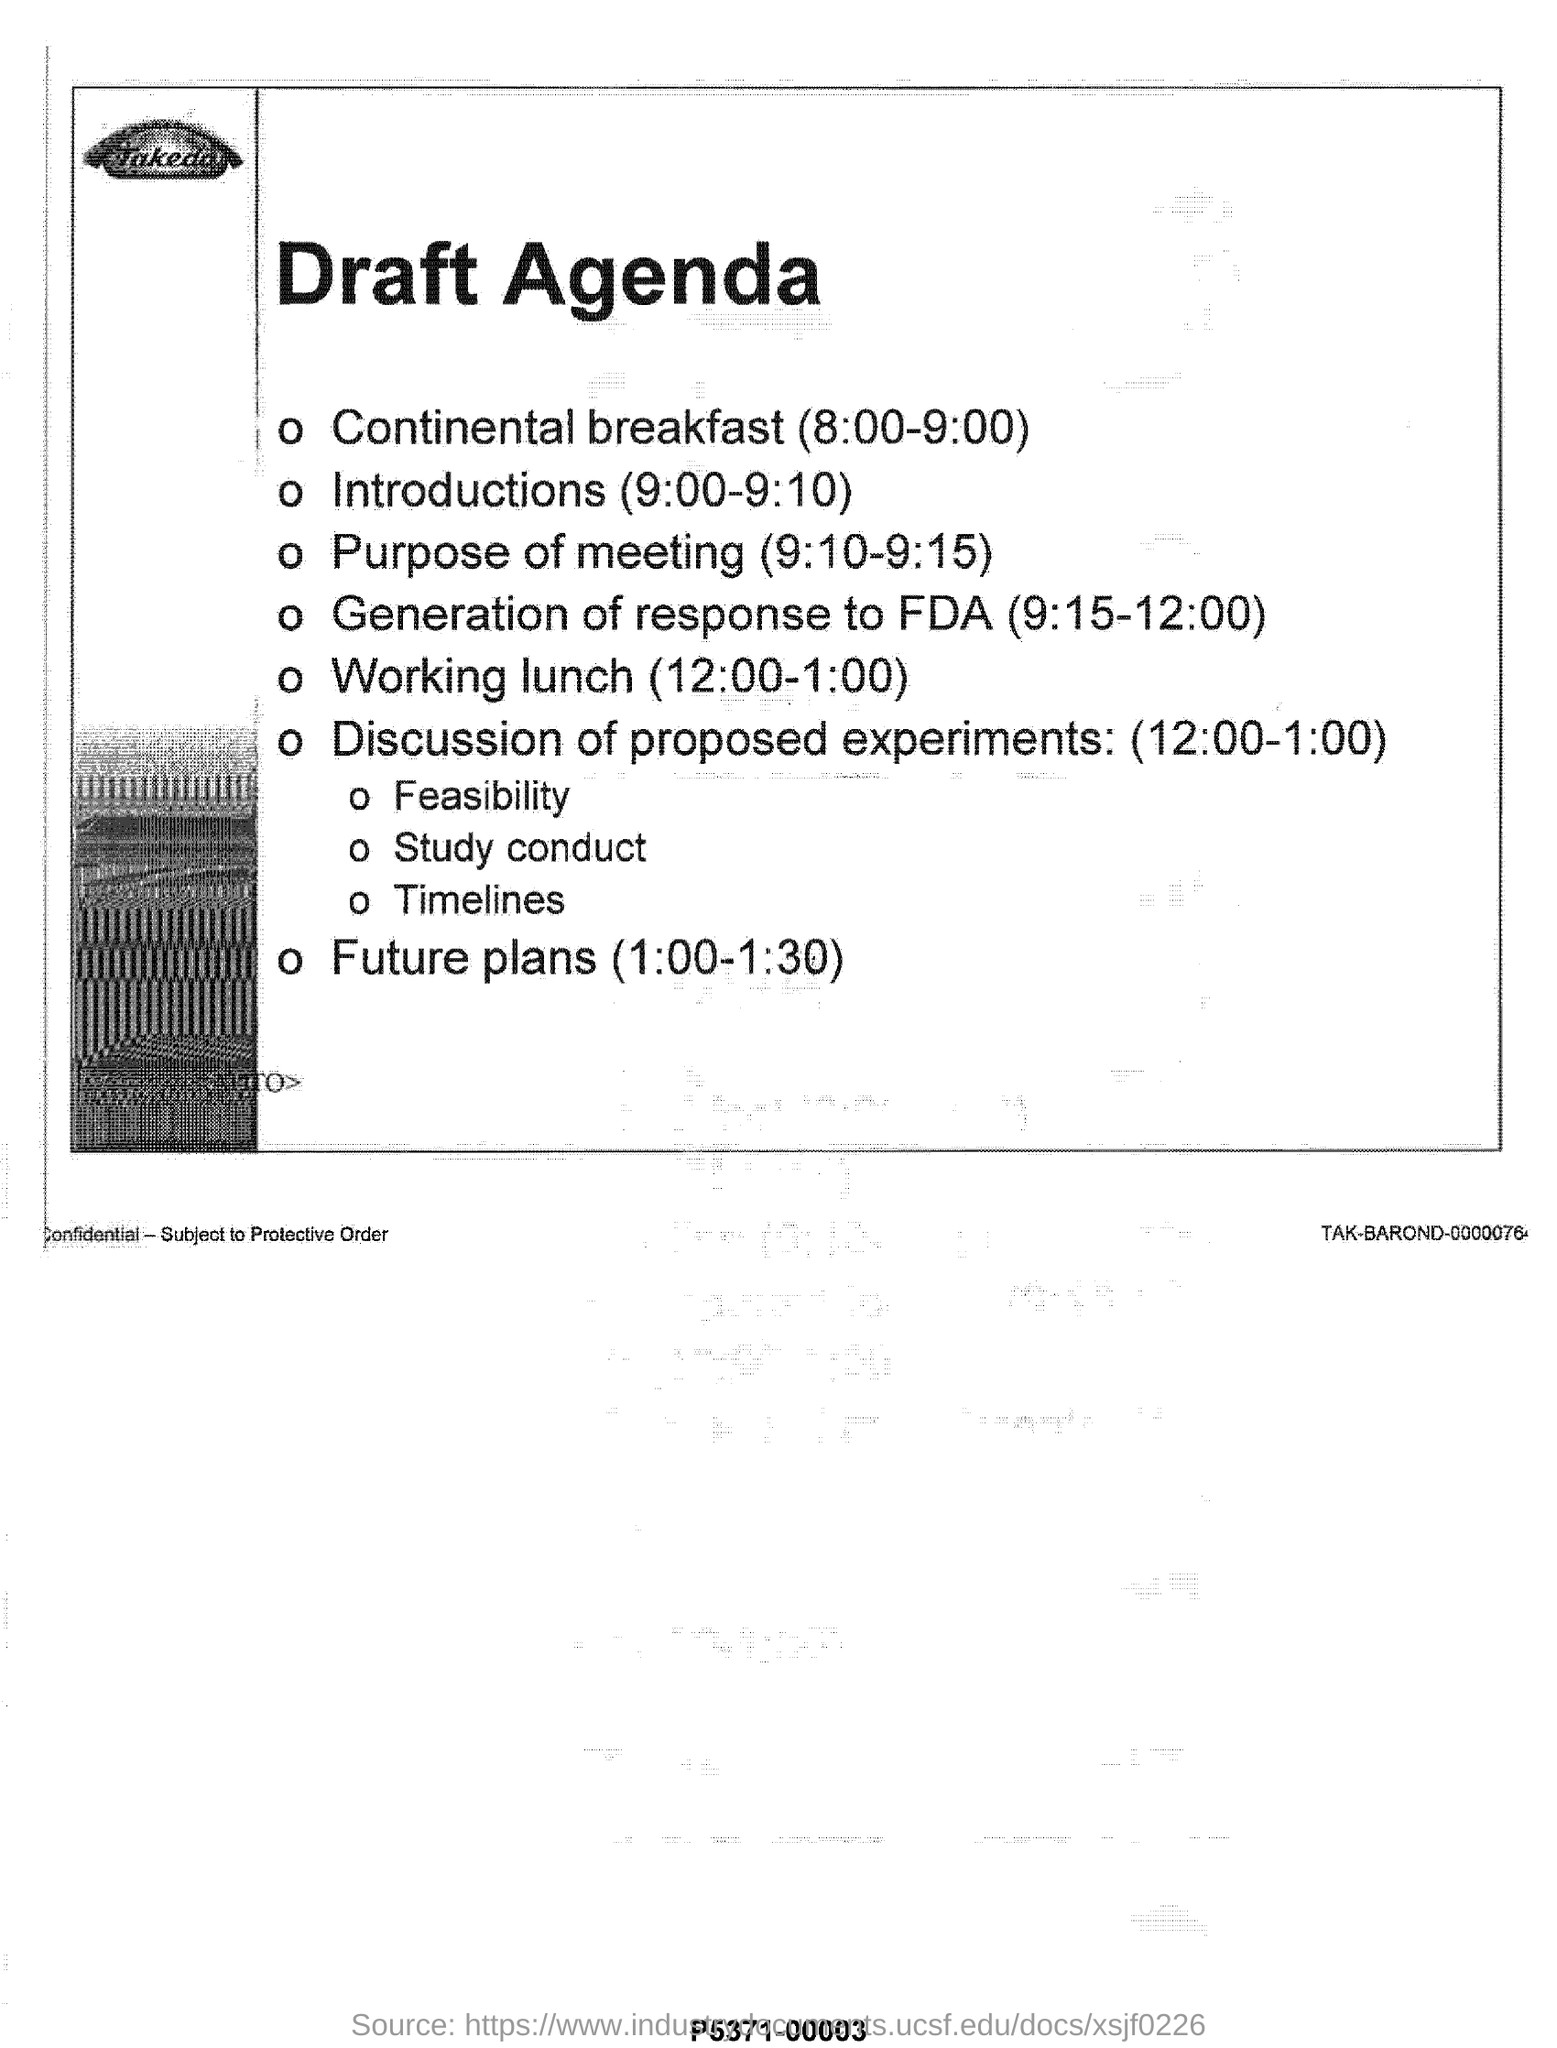Point out several critical features in this image. The timing for Continental Breakfast is from 8:00-9:00. The heading of the document reads "Draft Agenda. 